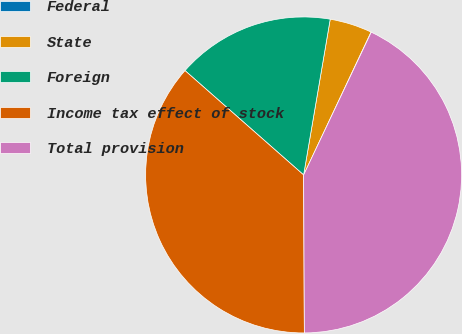Convert chart. <chart><loc_0><loc_0><loc_500><loc_500><pie_chart><fcel>Federal<fcel>State<fcel>Foreign<fcel>Income tax effect of stock<fcel>Total provision<nl><fcel>0.03%<fcel>4.32%<fcel>16.21%<fcel>36.56%<fcel>42.89%<nl></chart> 